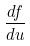<formula> <loc_0><loc_0><loc_500><loc_500>\frac { d f } { d u }</formula> 